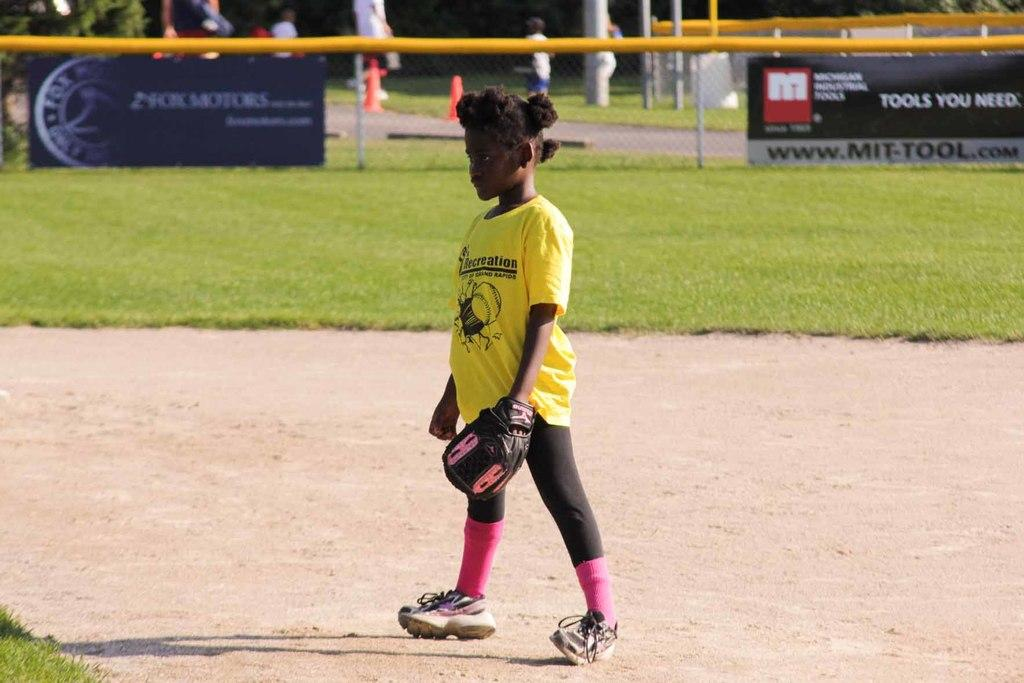<image>
Give a short and clear explanation of the subsequent image. A young boy wearing a yellow shirt with the word recreation on it 